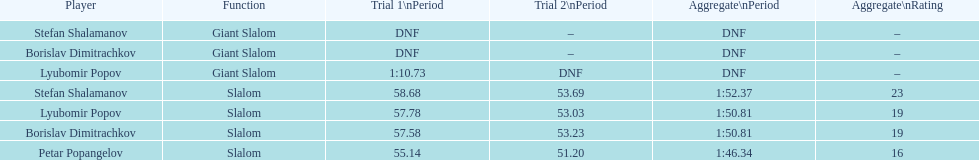Who was the other athlete who tied in rank with lyubomir popov? Borislav Dimitrachkov. 